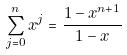Convert formula to latex. <formula><loc_0><loc_0><loc_500><loc_500>\sum _ { j = 0 } ^ { n } x ^ { j } = \frac { 1 - x ^ { n + 1 } } { 1 - x }</formula> 